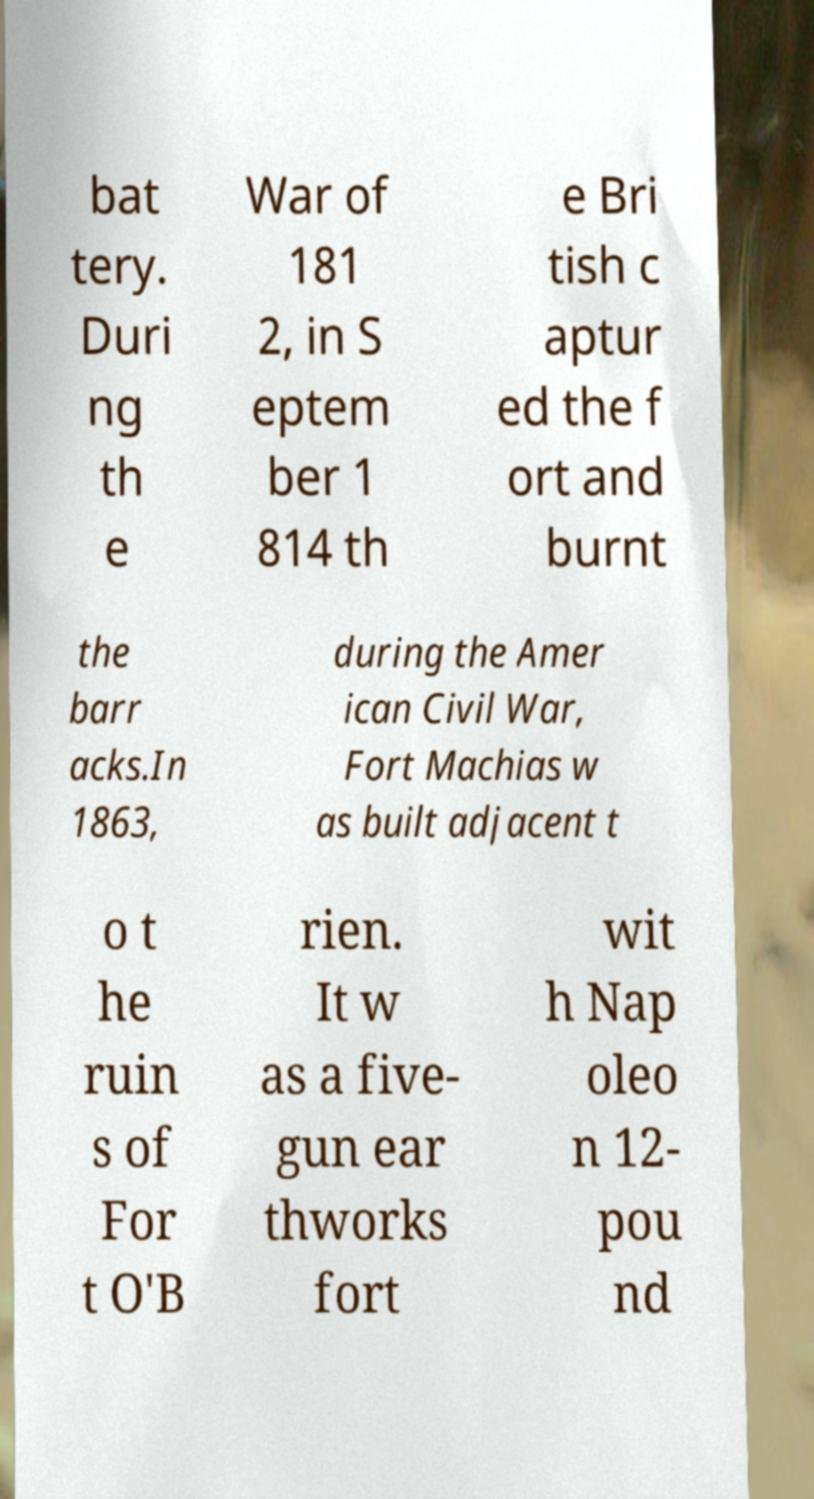For documentation purposes, I need the text within this image transcribed. Could you provide that? bat tery. Duri ng th e War of 181 2, in S eptem ber 1 814 th e Bri tish c aptur ed the f ort and burnt the barr acks.In 1863, during the Amer ican Civil War, Fort Machias w as built adjacent t o t he ruin s of For t O'B rien. It w as a five- gun ear thworks fort wit h Nap oleo n 12- pou nd 